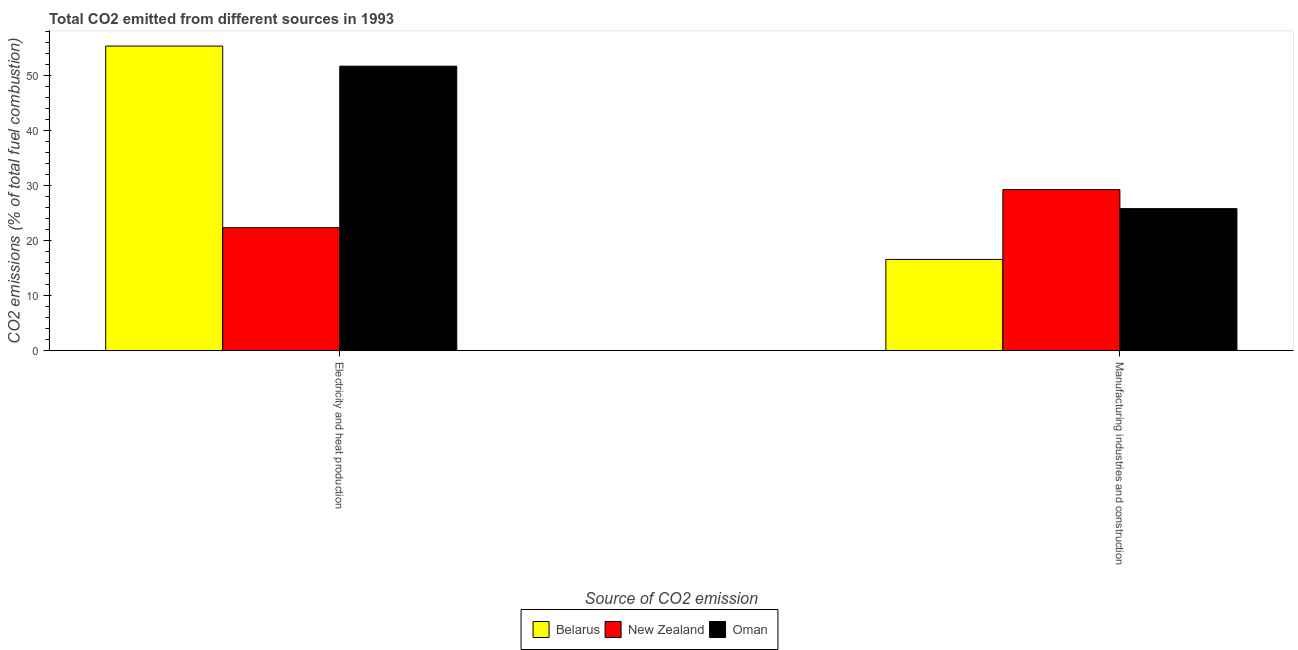Are the number of bars per tick equal to the number of legend labels?
Your answer should be very brief. Yes. Are the number of bars on each tick of the X-axis equal?
Keep it short and to the point. Yes. How many bars are there on the 2nd tick from the left?
Offer a terse response. 3. What is the label of the 1st group of bars from the left?
Provide a succinct answer. Electricity and heat production. What is the co2 emissions due to electricity and heat production in New Zealand?
Your answer should be compact. 22.35. Across all countries, what is the maximum co2 emissions due to manufacturing industries?
Keep it short and to the point. 29.27. Across all countries, what is the minimum co2 emissions due to manufacturing industries?
Make the answer very short. 16.58. In which country was the co2 emissions due to electricity and heat production maximum?
Give a very brief answer. Belarus. In which country was the co2 emissions due to electricity and heat production minimum?
Keep it short and to the point. New Zealand. What is the total co2 emissions due to manufacturing industries in the graph?
Give a very brief answer. 71.67. What is the difference between the co2 emissions due to manufacturing industries in Belarus and that in Oman?
Give a very brief answer. -9.23. What is the difference between the co2 emissions due to electricity and heat production in Oman and the co2 emissions due to manufacturing industries in Belarus?
Ensure brevity in your answer.  35.13. What is the average co2 emissions due to manufacturing industries per country?
Your answer should be very brief. 23.89. What is the difference between the co2 emissions due to electricity and heat production and co2 emissions due to manufacturing industries in Oman?
Your answer should be very brief. 25.9. What is the ratio of the co2 emissions due to electricity and heat production in Oman to that in Belarus?
Ensure brevity in your answer.  0.93. Is the co2 emissions due to electricity and heat production in Belarus less than that in Oman?
Ensure brevity in your answer.  No. What does the 3rd bar from the left in Manufacturing industries and construction represents?
Offer a terse response. Oman. What does the 2nd bar from the right in Electricity and heat production represents?
Offer a terse response. New Zealand. Are all the bars in the graph horizontal?
Give a very brief answer. No. How many countries are there in the graph?
Your response must be concise. 3. Are the values on the major ticks of Y-axis written in scientific E-notation?
Keep it short and to the point. No. Does the graph contain any zero values?
Offer a terse response. No. Where does the legend appear in the graph?
Provide a short and direct response. Bottom center. What is the title of the graph?
Offer a very short reply. Total CO2 emitted from different sources in 1993. What is the label or title of the X-axis?
Provide a short and direct response. Source of CO2 emission. What is the label or title of the Y-axis?
Give a very brief answer. CO2 emissions (% of total fuel combustion). What is the CO2 emissions (% of total fuel combustion) of Belarus in Electricity and heat production?
Your response must be concise. 55.37. What is the CO2 emissions (% of total fuel combustion) of New Zealand in Electricity and heat production?
Offer a terse response. 22.35. What is the CO2 emissions (% of total fuel combustion) in Oman in Electricity and heat production?
Ensure brevity in your answer.  51.71. What is the CO2 emissions (% of total fuel combustion) in Belarus in Manufacturing industries and construction?
Your answer should be compact. 16.58. What is the CO2 emissions (% of total fuel combustion) in New Zealand in Manufacturing industries and construction?
Ensure brevity in your answer.  29.27. What is the CO2 emissions (% of total fuel combustion) of Oman in Manufacturing industries and construction?
Keep it short and to the point. 25.82. Across all Source of CO2 emission, what is the maximum CO2 emissions (% of total fuel combustion) in Belarus?
Offer a very short reply. 55.37. Across all Source of CO2 emission, what is the maximum CO2 emissions (% of total fuel combustion) in New Zealand?
Offer a terse response. 29.27. Across all Source of CO2 emission, what is the maximum CO2 emissions (% of total fuel combustion) in Oman?
Offer a terse response. 51.71. Across all Source of CO2 emission, what is the minimum CO2 emissions (% of total fuel combustion) in Belarus?
Offer a terse response. 16.58. Across all Source of CO2 emission, what is the minimum CO2 emissions (% of total fuel combustion) in New Zealand?
Make the answer very short. 22.35. Across all Source of CO2 emission, what is the minimum CO2 emissions (% of total fuel combustion) of Oman?
Your response must be concise. 25.82. What is the total CO2 emissions (% of total fuel combustion) in Belarus in the graph?
Make the answer very short. 71.95. What is the total CO2 emissions (% of total fuel combustion) in New Zealand in the graph?
Your answer should be compact. 51.62. What is the total CO2 emissions (% of total fuel combustion) in Oman in the graph?
Your answer should be compact. 77.53. What is the difference between the CO2 emissions (% of total fuel combustion) in Belarus in Electricity and heat production and that in Manufacturing industries and construction?
Give a very brief answer. 38.79. What is the difference between the CO2 emissions (% of total fuel combustion) of New Zealand in Electricity and heat production and that in Manufacturing industries and construction?
Your answer should be compact. -6.92. What is the difference between the CO2 emissions (% of total fuel combustion) of Oman in Electricity and heat production and that in Manufacturing industries and construction?
Give a very brief answer. 25.9. What is the difference between the CO2 emissions (% of total fuel combustion) of Belarus in Electricity and heat production and the CO2 emissions (% of total fuel combustion) of New Zealand in Manufacturing industries and construction?
Make the answer very short. 26.1. What is the difference between the CO2 emissions (% of total fuel combustion) in Belarus in Electricity and heat production and the CO2 emissions (% of total fuel combustion) in Oman in Manufacturing industries and construction?
Offer a terse response. 29.55. What is the difference between the CO2 emissions (% of total fuel combustion) in New Zealand in Electricity and heat production and the CO2 emissions (% of total fuel combustion) in Oman in Manufacturing industries and construction?
Provide a succinct answer. -3.47. What is the average CO2 emissions (% of total fuel combustion) in Belarus per Source of CO2 emission?
Your answer should be very brief. 35.98. What is the average CO2 emissions (% of total fuel combustion) of New Zealand per Source of CO2 emission?
Give a very brief answer. 25.81. What is the average CO2 emissions (% of total fuel combustion) of Oman per Source of CO2 emission?
Your answer should be very brief. 38.76. What is the difference between the CO2 emissions (% of total fuel combustion) in Belarus and CO2 emissions (% of total fuel combustion) in New Zealand in Electricity and heat production?
Ensure brevity in your answer.  33.02. What is the difference between the CO2 emissions (% of total fuel combustion) in Belarus and CO2 emissions (% of total fuel combustion) in Oman in Electricity and heat production?
Keep it short and to the point. 3.66. What is the difference between the CO2 emissions (% of total fuel combustion) in New Zealand and CO2 emissions (% of total fuel combustion) in Oman in Electricity and heat production?
Make the answer very short. -29.37. What is the difference between the CO2 emissions (% of total fuel combustion) of Belarus and CO2 emissions (% of total fuel combustion) of New Zealand in Manufacturing industries and construction?
Offer a very short reply. -12.69. What is the difference between the CO2 emissions (% of total fuel combustion) in Belarus and CO2 emissions (% of total fuel combustion) in Oman in Manufacturing industries and construction?
Provide a short and direct response. -9.23. What is the difference between the CO2 emissions (% of total fuel combustion) of New Zealand and CO2 emissions (% of total fuel combustion) of Oman in Manufacturing industries and construction?
Give a very brief answer. 3.45. What is the ratio of the CO2 emissions (% of total fuel combustion) in Belarus in Electricity and heat production to that in Manufacturing industries and construction?
Ensure brevity in your answer.  3.34. What is the ratio of the CO2 emissions (% of total fuel combustion) of New Zealand in Electricity and heat production to that in Manufacturing industries and construction?
Your response must be concise. 0.76. What is the ratio of the CO2 emissions (% of total fuel combustion) in Oman in Electricity and heat production to that in Manufacturing industries and construction?
Your answer should be compact. 2. What is the difference between the highest and the second highest CO2 emissions (% of total fuel combustion) in Belarus?
Ensure brevity in your answer.  38.79. What is the difference between the highest and the second highest CO2 emissions (% of total fuel combustion) in New Zealand?
Your answer should be compact. 6.92. What is the difference between the highest and the second highest CO2 emissions (% of total fuel combustion) of Oman?
Your answer should be very brief. 25.9. What is the difference between the highest and the lowest CO2 emissions (% of total fuel combustion) in Belarus?
Your answer should be compact. 38.79. What is the difference between the highest and the lowest CO2 emissions (% of total fuel combustion) in New Zealand?
Your answer should be compact. 6.92. What is the difference between the highest and the lowest CO2 emissions (% of total fuel combustion) of Oman?
Offer a very short reply. 25.9. 